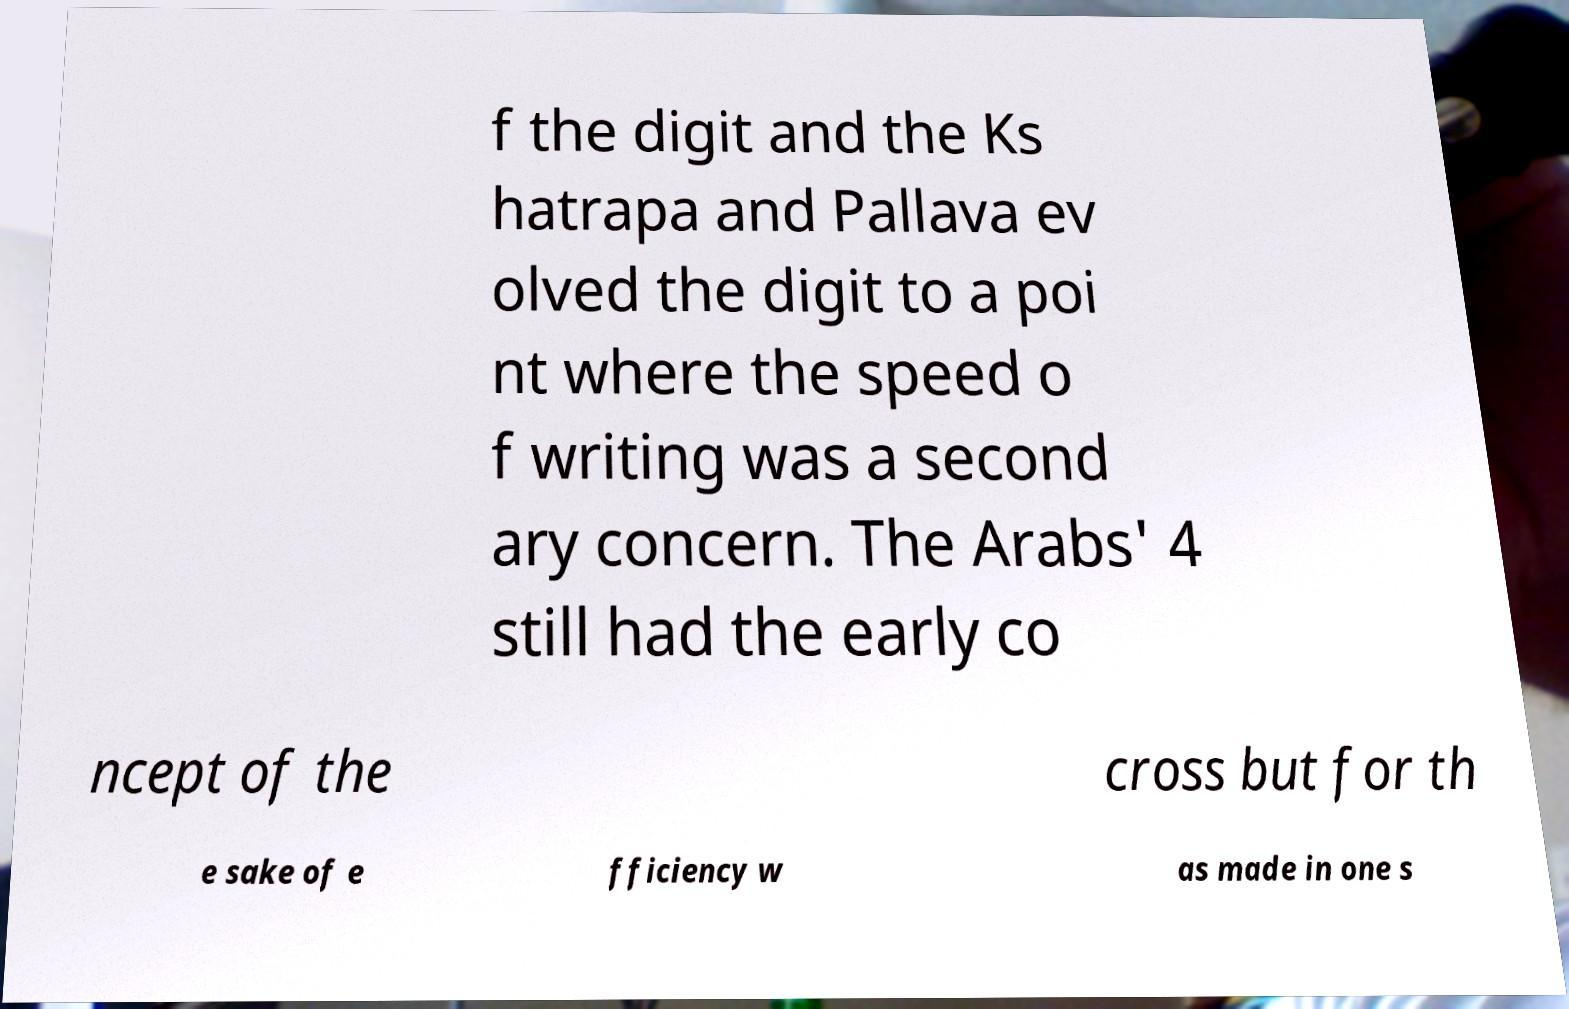Please identify and transcribe the text found in this image. f the digit and the Ks hatrapa and Pallava ev olved the digit to a poi nt where the speed o f writing was a second ary concern. The Arabs' 4 still had the early co ncept of the cross but for th e sake of e fficiency w as made in one s 